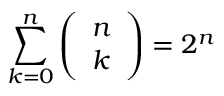<formula> <loc_0><loc_0><loc_500><loc_500>\sum _ { k = 0 } ^ { n } \left ( \begin{array} { l } { n } \\ { k } \end{array} \right ) = 2 ^ { n }</formula> 